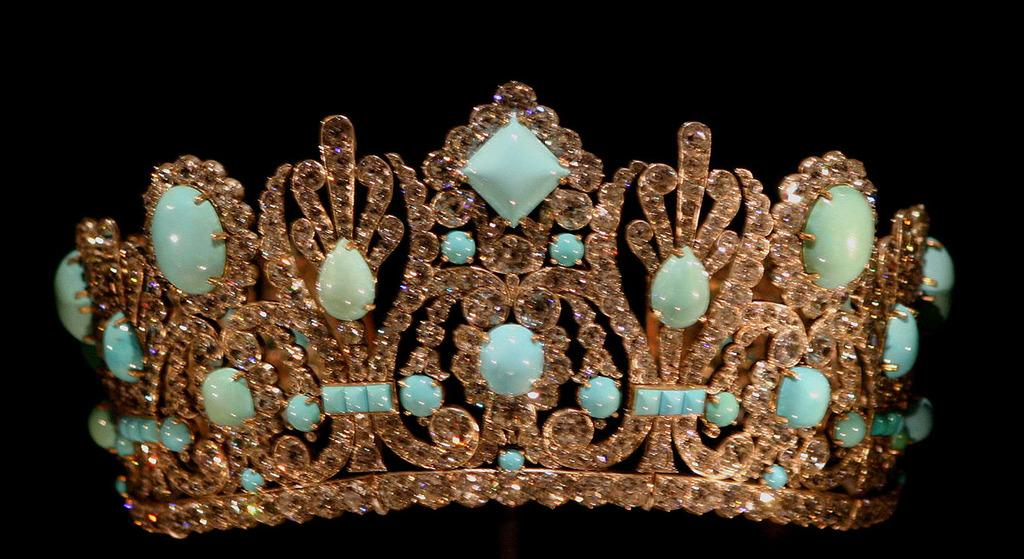What is the main object in the picture? There is a crown in the picture. What material is the crown made of? The crown is made of stones. What can be observed about the background of the image? The background of the image is dark. What type of development is taking place in the image? There is no development taking place in the image; it features a crown made of stones against a dark background. What religious symbolism can be seen in the image? There is no religious symbolism present in the image; it only features a crown made of stones. 